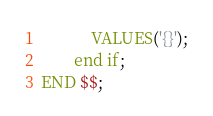Convert code to text. <code><loc_0><loc_0><loc_500><loc_500><_SQL_>            VALUES('{}');
        end if;
END $$;</code> 